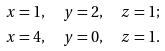Convert formula to latex. <formula><loc_0><loc_0><loc_500><loc_500>x & = 1 , \quad y = 2 , \quad z = 1 ; \\ x & = 4 , \quad y = 0 , \quad z = 1 .</formula> 